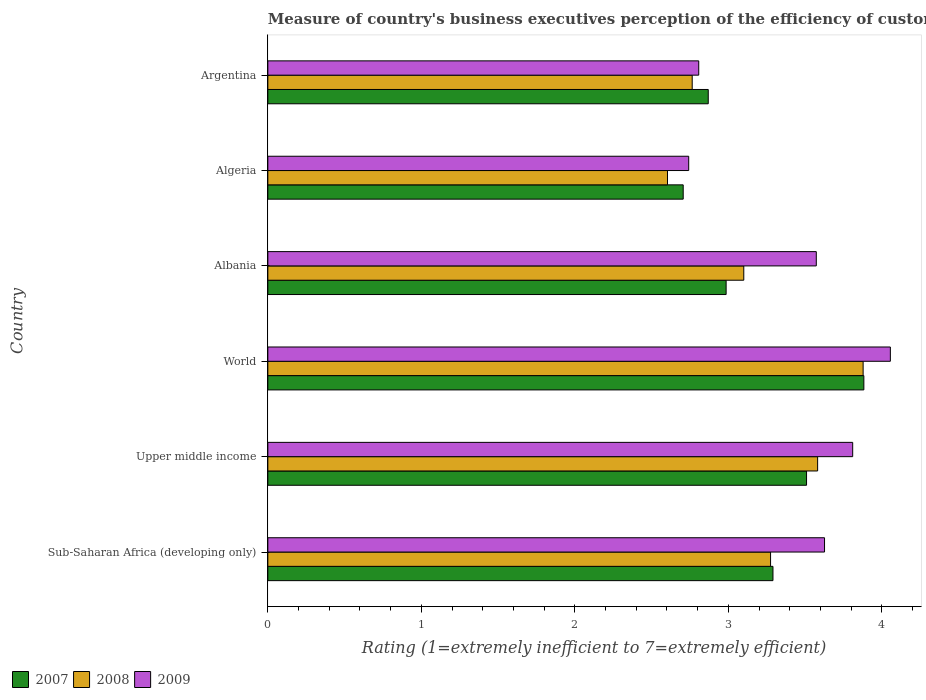How many groups of bars are there?
Provide a short and direct response. 6. Are the number of bars per tick equal to the number of legend labels?
Give a very brief answer. Yes. Are the number of bars on each tick of the Y-axis equal?
Offer a terse response. Yes. In how many cases, is the number of bars for a given country not equal to the number of legend labels?
Offer a very short reply. 0. What is the rating of the efficiency of customs procedure in 2008 in Sub-Saharan Africa (developing only)?
Make the answer very short. 3.27. Across all countries, what is the maximum rating of the efficiency of customs procedure in 2009?
Offer a terse response. 4.06. Across all countries, what is the minimum rating of the efficiency of customs procedure in 2009?
Make the answer very short. 2.74. In which country was the rating of the efficiency of customs procedure in 2007 maximum?
Offer a very short reply. World. In which country was the rating of the efficiency of customs procedure in 2009 minimum?
Offer a very short reply. Algeria. What is the total rating of the efficiency of customs procedure in 2008 in the graph?
Give a very brief answer. 19.2. What is the difference between the rating of the efficiency of customs procedure in 2008 in Argentina and that in World?
Provide a short and direct response. -1.11. What is the difference between the rating of the efficiency of customs procedure in 2008 in Upper middle income and the rating of the efficiency of customs procedure in 2009 in Sub-Saharan Africa (developing only)?
Make the answer very short. -0.04. What is the average rating of the efficiency of customs procedure in 2007 per country?
Make the answer very short. 3.21. What is the difference between the rating of the efficiency of customs procedure in 2008 and rating of the efficiency of customs procedure in 2007 in Argentina?
Your answer should be very brief. -0.1. What is the ratio of the rating of the efficiency of customs procedure in 2009 in Sub-Saharan Africa (developing only) to that in Upper middle income?
Ensure brevity in your answer.  0.95. Is the difference between the rating of the efficiency of customs procedure in 2008 in Algeria and Sub-Saharan Africa (developing only) greater than the difference between the rating of the efficiency of customs procedure in 2007 in Algeria and Sub-Saharan Africa (developing only)?
Provide a short and direct response. No. What is the difference between the highest and the second highest rating of the efficiency of customs procedure in 2008?
Ensure brevity in your answer.  0.3. What is the difference between the highest and the lowest rating of the efficiency of customs procedure in 2007?
Your answer should be compact. 1.18. In how many countries, is the rating of the efficiency of customs procedure in 2008 greater than the average rating of the efficiency of customs procedure in 2008 taken over all countries?
Your answer should be very brief. 3. Is the sum of the rating of the efficiency of customs procedure in 2008 in Albania and Argentina greater than the maximum rating of the efficiency of customs procedure in 2007 across all countries?
Your answer should be compact. Yes. What does the 2nd bar from the top in Albania represents?
Ensure brevity in your answer.  2008. Is it the case that in every country, the sum of the rating of the efficiency of customs procedure in 2008 and rating of the efficiency of customs procedure in 2009 is greater than the rating of the efficiency of customs procedure in 2007?
Give a very brief answer. Yes. Are all the bars in the graph horizontal?
Your answer should be compact. Yes. What is the difference between two consecutive major ticks on the X-axis?
Your response must be concise. 1. Does the graph contain any zero values?
Keep it short and to the point. No. How many legend labels are there?
Make the answer very short. 3. How are the legend labels stacked?
Provide a short and direct response. Horizontal. What is the title of the graph?
Provide a succinct answer. Measure of country's business executives perception of the efficiency of customs procedures. What is the label or title of the X-axis?
Give a very brief answer. Rating (1=extremely inefficient to 7=extremely efficient). What is the Rating (1=extremely inefficient to 7=extremely efficient) in 2007 in Sub-Saharan Africa (developing only)?
Offer a terse response. 3.29. What is the Rating (1=extremely inefficient to 7=extremely efficient) in 2008 in Sub-Saharan Africa (developing only)?
Your answer should be very brief. 3.27. What is the Rating (1=extremely inefficient to 7=extremely efficient) of 2009 in Sub-Saharan Africa (developing only)?
Your answer should be very brief. 3.63. What is the Rating (1=extremely inefficient to 7=extremely efficient) in 2007 in Upper middle income?
Offer a terse response. 3.51. What is the Rating (1=extremely inefficient to 7=extremely efficient) in 2008 in Upper middle income?
Your answer should be compact. 3.58. What is the Rating (1=extremely inefficient to 7=extremely efficient) of 2009 in Upper middle income?
Offer a very short reply. 3.81. What is the Rating (1=extremely inefficient to 7=extremely efficient) in 2007 in World?
Your response must be concise. 3.88. What is the Rating (1=extremely inefficient to 7=extremely efficient) in 2008 in World?
Keep it short and to the point. 3.88. What is the Rating (1=extremely inefficient to 7=extremely efficient) of 2009 in World?
Give a very brief answer. 4.06. What is the Rating (1=extremely inefficient to 7=extremely efficient) of 2007 in Albania?
Offer a terse response. 2.99. What is the Rating (1=extremely inefficient to 7=extremely efficient) in 2008 in Albania?
Keep it short and to the point. 3.1. What is the Rating (1=extremely inefficient to 7=extremely efficient) in 2009 in Albania?
Provide a short and direct response. 3.57. What is the Rating (1=extremely inefficient to 7=extremely efficient) in 2007 in Algeria?
Offer a terse response. 2.71. What is the Rating (1=extremely inefficient to 7=extremely efficient) of 2008 in Algeria?
Ensure brevity in your answer.  2.6. What is the Rating (1=extremely inefficient to 7=extremely efficient) in 2009 in Algeria?
Provide a short and direct response. 2.74. What is the Rating (1=extremely inefficient to 7=extremely efficient) in 2007 in Argentina?
Ensure brevity in your answer.  2.87. What is the Rating (1=extremely inefficient to 7=extremely efficient) in 2008 in Argentina?
Keep it short and to the point. 2.76. What is the Rating (1=extremely inefficient to 7=extremely efficient) of 2009 in Argentina?
Ensure brevity in your answer.  2.81. Across all countries, what is the maximum Rating (1=extremely inefficient to 7=extremely efficient) in 2007?
Your answer should be very brief. 3.88. Across all countries, what is the maximum Rating (1=extremely inefficient to 7=extremely efficient) of 2008?
Keep it short and to the point. 3.88. Across all countries, what is the maximum Rating (1=extremely inefficient to 7=extremely efficient) of 2009?
Keep it short and to the point. 4.06. Across all countries, what is the minimum Rating (1=extremely inefficient to 7=extremely efficient) in 2007?
Ensure brevity in your answer.  2.71. Across all countries, what is the minimum Rating (1=extremely inefficient to 7=extremely efficient) of 2008?
Offer a very short reply. 2.6. Across all countries, what is the minimum Rating (1=extremely inefficient to 7=extremely efficient) in 2009?
Offer a terse response. 2.74. What is the total Rating (1=extremely inefficient to 7=extremely efficient) in 2007 in the graph?
Offer a very short reply. 19.24. What is the total Rating (1=extremely inefficient to 7=extremely efficient) of 2008 in the graph?
Provide a short and direct response. 19.2. What is the total Rating (1=extremely inefficient to 7=extremely efficient) in 2009 in the graph?
Your answer should be very brief. 20.61. What is the difference between the Rating (1=extremely inefficient to 7=extremely efficient) in 2007 in Sub-Saharan Africa (developing only) and that in Upper middle income?
Make the answer very short. -0.22. What is the difference between the Rating (1=extremely inefficient to 7=extremely efficient) in 2008 in Sub-Saharan Africa (developing only) and that in Upper middle income?
Your answer should be very brief. -0.31. What is the difference between the Rating (1=extremely inefficient to 7=extremely efficient) in 2009 in Sub-Saharan Africa (developing only) and that in Upper middle income?
Ensure brevity in your answer.  -0.18. What is the difference between the Rating (1=extremely inefficient to 7=extremely efficient) in 2007 in Sub-Saharan Africa (developing only) and that in World?
Ensure brevity in your answer.  -0.59. What is the difference between the Rating (1=extremely inefficient to 7=extremely efficient) of 2008 in Sub-Saharan Africa (developing only) and that in World?
Make the answer very short. -0.6. What is the difference between the Rating (1=extremely inefficient to 7=extremely efficient) in 2009 in Sub-Saharan Africa (developing only) and that in World?
Ensure brevity in your answer.  -0.43. What is the difference between the Rating (1=extremely inefficient to 7=extremely efficient) of 2007 in Sub-Saharan Africa (developing only) and that in Albania?
Provide a succinct answer. 0.31. What is the difference between the Rating (1=extremely inefficient to 7=extremely efficient) of 2008 in Sub-Saharan Africa (developing only) and that in Albania?
Provide a short and direct response. 0.17. What is the difference between the Rating (1=extremely inefficient to 7=extremely efficient) of 2009 in Sub-Saharan Africa (developing only) and that in Albania?
Your answer should be compact. 0.05. What is the difference between the Rating (1=extremely inefficient to 7=extremely efficient) of 2007 in Sub-Saharan Africa (developing only) and that in Algeria?
Make the answer very short. 0.58. What is the difference between the Rating (1=extremely inefficient to 7=extremely efficient) in 2008 in Sub-Saharan Africa (developing only) and that in Algeria?
Your answer should be very brief. 0.67. What is the difference between the Rating (1=extremely inefficient to 7=extremely efficient) in 2009 in Sub-Saharan Africa (developing only) and that in Algeria?
Your answer should be very brief. 0.88. What is the difference between the Rating (1=extremely inefficient to 7=extremely efficient) in 2007 in Sub-Saharan Africa (developing only) and that in Argentina?
Your response must be concise. 0.42. What is the difference between the Rating (1=extremely inefficient to 7=extremely efficient) of 2008 in Sub-Saharan Africa (developing only) and that in Argentina?
Provide a short and direct response. 0.51. What is the difference between the Rating (1=extremely inefficient to 7=extremely efficient) of 2009 in Sub-Saharan Africa (developing only) and that in Argentina?
Provide a short and direct response. 0.82. What is the difference between the Rating (1=extremely inefficient to 7=extremely efficient) in 2007 in Upper middle income and that in World?
Provide a short and direct response. -0.37. What is the difference between the Rating (1=extremely inefficient to 7=extremely efficient) in 2008 in Upper middle income and that in World?
Provide a short and direct response. -0.3. What is the difference between the Rating (1=extremely inefficient to 7=extremely efficient) of 2009 in Upper middle income and that in World?
Give a very brief answer. -0.25. What is the difference between the Rating (1=extremely inefficient to 7=extremely efficient) of 2007 in Upper middle income and that in Albania?
Provide a succinct answer. 0.52. What is the difference between the Rating (1=extremely inefficient to 7=extremely efficient) of 2008 in Upper middle income and that in Albania?
Provide a short and direct response. 0.48. What is the difference between the Rating (1=extremely inefficient to 7=extremely efficient) of 2009 in Upper middle income and that in Albania?
Ensure brevity in your answer.  0.24. What is the difference between the Rating (1=extremely inefficient to 7=extremely efficient) in 2007 in Upper middle income and that in Algeria?
Your response must be concise. 0.8. What is the difference between the Rating (1=extremely inefficient to 7=extremely efficient) of 2008 in Upper middle income and that in Algeria?
Give a very brief answer. 0.98. What is the difference between the Rating (1=extremely inefficient to 7=extremely efficient) of 2009 in Upper middle income and that in Algeria?
Offer a very short reply. 1.07. What is the difference between the Rating (1=extremely inefficient to 7=extremely efficient) in 2007 in Upper middle income and that in Argentina?
Make the answer very short. 0.64. What is the difference between the Rating (1=extremely inefficient to 7=extremely efficient) in 2008 in Upper middle income and that in Argentina?
Ensure brevity in your answer.  0.82. What is the difference between the Rating (1=extremely inefficient to 7=extremely efficient) in 2007 in World and that in Albania?
Keep it short and to the point. 0.9. What is the difference between the Rating (1=extremely inefficient to 7=extremely efficient) in 2008 in World and that in Albania?
Provide a short and direct response. 0.78. What is the difference between the Rating (1=extremely inefficient to 7=extremely efficient) of 2009 in World and that in Albania?
Your answer should be compact. 0.48. What is the difference between the Rating (1=extremely inefficient to 7=extremely efficient) in 2007 in World and that in Algeria?
Ensure brevity in your answer.  1.18. What is the difference between the Rating (1=extremely inefficient to 7=extremely efficient) of 2008 in World and that in Algeria?
Provide a succinct answer. 1.27. What is the difference between the Rating (1=extremely inefficient to 7=extremely efficient) in 2009 in World and that in Algeria?
Offer a very short reply. 1.31. What is the difference between the Rating (1=extremely inefficient to 7=extremely efficient) of 2007 in World and that in Argentina?
Your answer should be very brief. 1.01. What is the difference between the Rating (1=extremely inefficient to 7=extremely efficient) in 2008 in World and that in Argentina?
Your answer should be very brief. 1.11. What is the difference between the Rating (1=extremely inefficient to 7=extremely efficient) of 2009 in World and that in Argentina?
Provide a short and direct response. 1.25. What is the difference between the Rating (1=extremely inefficient to 7=extremely efficient) of 2007 in Albania and that in Algeria?
Offer a very short reply. 0.28. What is the difference between the Rating (1=extremely inefficient to 7=extremely efficient) of 2008 in Albania and that in Algeria?
Give a very brief answer. 0.5. What is the difference between the Rating (1=extremely inefficient to 7=extremely efficient) in 2009 in Albania and that in Algeria?
Make the answer very short. 0.83. What is the difference between the Rating (1=extremely inefficient to 7=extremely efficient) of 2007 in Albania and that in Argentina?
Offer a very short reply. 0.12. What is the difference between the Rating (1=extremely inefficient to 7=extremely efficient) of 2008 in Albania and that in Argentina?
Ensure brevity in your answer.  0.34. What is the difference between the Rating (1=extremely inefficient to 7=extremely efficient) in 2009 in Albania and that in Argentina?
Ensure brevity in your answer.  0.77. What is the difference between the Rating (1=extremely inefficient to 7=extremely efficient) of 2007 in Algeria and that in Argentina?
Keep it short and to the point. -0.16. What is the difference between the Rating (1=extremely inefficient to 7=extremely efficient) of 2008 in Algeria and that in Argentina?
Your answer should be very brief. -0.16. What is the difference between the Rating (1=extremely inefficient to 7=extremely efficient) of 2009 in Algeria and that in Argentina?
Your answer should be compact. -0.07. What is the difference between the Rating (1=extremely inefficient to 7=extremely efficient) of 2007 in Sub-Saharan Africa (developing only) and the Rating (1=extremely inefficient to 7=extremely efficient) of 2008 in Upper middle income?
Your answer should be compact. -0.29. What is the difference between the Rating (1=extremely inefficient to 7=extremely efficient) of 2007 in Sub-Saharan Africa (developing only) and the Rating (1=extremely inefficient to 7=extremely efficient) of 2009 in Upper middle income?
Your answer should be compact. -0.52. What is the difference between the Rating (1=extremely inefficient to 7=extremely efficient) of 2008 in Sub-Saharan Africa (developing only) and the Rating (1=extremely inefficient to 7=extremely efficient) of 2009 in Upper middle income?
Provide a succinct answer. -0.54. What is the difference between the Rating (1=extremely inefficient to 7=extremely efficient) of 2007 in Sub-Saharan Africa (developing only) and the Rating (1=extremely inefficient to 7=extremely efficient) of 2008 in World?
Make the answer very short. -0.59. What is the difference between the Rating (1=extremely inefficient to 7=extremely efficient) of 2007 in Sub-Saharan Africa (developing only) and the Rating (1=extremely inefficient to 7=extremely efficient) of 2009 in World?
Provide a short and direct response. -0.76. What is the difference between the Rating (1=extremely inefficient to 7=extremely efficient) in 2008 in Sub-Saharan Africa (developing only) and the Rating (1=extremely inefficient to 7=extremely efficient) in 2009 in World?
Make the answer very short. -0.78. What is the difference between the Rating (1=extremely inefficient to 7=extremely efficient) in 2007 in Sub-Saharan Africa (developing only) and the Rating (1=extremely inefficient to 7=extremely efficient) in 2008 in Albania?
Make the answer very short. 0.19. What is the difference between the Rating (1=extremely inefficient to 7=extremely efficient) in 2007 in Sub-Saharan Africa (developing only) and the Rating (1=extremely inefficient to 7=extremely efficient) in 2009 in Albania?
Your response must be concise. -0.28. What is the difference between the Rating (1=extremely inefficient to 7=extremely efficient) in 2008 in Sub-Saharan Africa (developing only) and the Rating (1=extremely inefficient to 7=extremely efficient) in 2009 in Albania?
Give a very brief answer. -0.3. What is the difference between the Rating (1=extremely inefficient to 7=extremely efficient) in 2007 in Sub-Saharan Africa (developing only) and the Rating (1=extremely inefficient to 7=extremely efficient) in 2008 in Algeria?
Offer a very short reply. 0.69. What is the difference between the Rating (1=extremely inefficient to 7=extremely efficient) in 2007 in Sub-Saharan Africa (developing only) and the Rating (1=extremely inefficient to 7=extremely efficient) in 2009 in Algeria?
Your answer should be very brief. 0.55. What is the difference between the Rating (1=extremely inefficient to 7=extremely efficient) of 2008 in Sub-Saharan Africa (developing only) and the Rating (1=extremely inefficient to 7=extremely efficient) of 2009 in Algeria?
Offer a terse response. 0.53. What is the difference between the Rating (1=extremely inefficient to 7=extremely efficient) of 2007 in Sub-Saharan Africa (developing only) and the Rating (1=extremely inefficient to 7=extremely efficient) of 2008 in Argentina?
Provide a succinct answer. 0.53. What is the difference between the Rating (1=extremely inefficient to 7=extremely efficient) of 2007 in Sub-Saharan Africa (developing only) and the Rating (1=extremely inefficient to 7=extremely efficient) of 2009 in Argentina?
Your response must be concise. 0.48. What is the difference between the Rating (1=extremely inefficient to 7=extremely efficient) in 2008 in Sub-Saharan Africa (developing only) and the Rating (1=extremely inefficient to 7=extremely efficient) in 2009 in Argentina?
Provide a succinct answer. 0.47. What is the difference between the Rating (1=extremely inefficient to 7=extremely efficient) of 2007 in Upper middle income and the Rating (1=extremely inefficient to 7=extremely efficient) of 2008 in World?
Offer a terse response. -0.37. What is the difference between the Rating (1=extremely inefficient to 7=extremely efficient) of 2007 in Upper middle income and the Rating (1=extremely inefficient to 7=extremely efficient) of 2009 in World?
Give a very brief answer. -0.55. What is the difference between the Rating (1=extremely inefficient to 7=extremely efficient) in 2008 in Upper middle income and the Rating (1=extremely inefficient to 7=extremely efficient) in 2009 in World?
Provide a succinct answer. -0.47. What is the difference between the Rating (1=extremely inefficient to 7=extremely efficient) of 2007 in Upper middle income and the Rating (1=extremely inefficient to 7=extremely efficient) of 2008 in Albania?
Keep it short and to the point. 0.41. What is the difference between the Rating (1=extremely inefficient to 7=extremely efficient) of 2007 in Upper middle income and the Rating (1=extremely inefficient to 7=extremely efficient) of 2009 in Albania?
Offer a very short reply. -0.06. What is the difference between the Rating (1=extremely inefficient to 7=extremely efficient) of 2008 in Upper middle income and the Rating (1=extremely inefficient to 7=extremely efficient) of 2009 in Albania?
Your answer should be very brief. 0.01. What is the difference between the Rating (1=extremely inefficient to 7=extremely efficient) in 2007 in Upper middle income and the Rating (1=extremely inefficient to 7=extremely efficient) in 2008 in Algeria?
Make the answer very short. 0.91. What is the difference between the Rating (1=extremely inefficient to 7=extremely efficient) of 2007 in Upper middle income and the Rating (1=extremely inefficient to 7=extremely efficient) of 2009 in Algeria?
Ensure brevity in your answer.  0.77. What is the difference between the Rating (1=extremely inefficient to 7=extremely efficient) of 2008 in Upper middle income and the Rating (1=extremely inefficient to 7=extremely efficient) of 2009 in Algeria?
Keep it short and to the point. 0.84. What is the difference between the Rating (1=extremely inefficient to 7=extremely efficient) in 2007 in Upper middle income and the Rating (1=extremely inefficient to 7=extremely efficient) in 2008 in Argentina?
Your answer should be compact. 0.74. What is the difference between the Rating (1=extremely inefficient to 7=extremely efficient) in 2007 in Upper middle income and the Rating (1=extremely inefficient to 7=extremely efficient) in 2009 in Argentina?
Give a very brief answer. 0.7. What is the difference between the Rating (1=extremely inefficient to 7=extremely efficient) in 2008 in Upper middle income and the Rating (1=extremely inefficient to 7=extremely efficient) in 2009 in Argentina?
Provide a short and direct response. 0.77. What is the difference between the Rating (1=extremely inefficient to 7=extremely efficient) in 2007 in World and the Rating (1=extremely inefficient to 7=extremely efficient) in 2008 in Albania?
Provide a succinct answer. 0.78. What is the difference between the Rating (1=extremely inefficient to 7=extremely efficient) in 2007 in World and the Rating (1=extremely inefficient to 7=extremely efficient) in 2009 in Albania?
Keep it short and to the point. 0.31. What is the difference between the Rating (1=extremely inefficient to 7=extremely efficient) in 2008 in World and the Rating (1=extremely inefficient to 7=extremely efficient) in 2009 in Albania?
Keep it short and to the point. 0.31. What is the difference between the Rating (1=extremely inefficient to 7=extremely efficient) of 2007 in World and the Rating (1=extremely inefficient to 7=extremely efficient) of 2008 in Algeria?
Offer a very short reply. 1.28. What is the difference between the Rating (1=extremely inefficient to 7=extremely efficient) of 2007 in World and the Rating (1=extremely inefficient to 7=extremely efficient) of 2009 in Algeria?
Your response must be concise. 1.14. What is the difference between the Rating (1=extremely inefficient to 7=extremely efficient) of 2008 in World and the Rating (1=extremely inefficient to 7=extremely efficient) of 2009 in Algeria?
Make the answer very short. 1.14. What is the difference between the Rating (1=extremely inefficient to 7=extremely efficient) in 2007 in World and the Rating (1=extremely inefficient to 7=extremely efficient) in 2008 in Argentina?
Your answer should be very brief. 1.12. What is the difference between the Rating (1=extremely inefficient to 7=extremely efficient) in 2007 in World and the Rating (1=extremely inefficient to 7=extremely efficient) in 2009 in Argentina?
Give a very brief answer. 1.08. What is the difference between the Rating (1=extremely inefficient to 7=extremely efficient) of 2008 in World and the Rating (1=extremely inefficient to 7=extremely efficient) of 2009 in Argentina?
Offer a terse response. 1.07. What is the difference between the Rating (1=extremely inefficient to 7=extremely efficient) in 2007 in Albania and the Rating (1=extremely inefficient to 7=extremely efficient) in 2008 in Algeria?
Offer a terse response. 0.38. What is the difference between the Rating (1=extremely inefficient to 7=extremely efficient) in 2007 in Albania and the Rating (1=extremely inefficient to 7=extremely efficient) in 2009 in Algeria?
Give a very brief answer. 0.24. What is the difference between the Rating (1=extremely inefficient to 7=extremely efficient) in 2008 in Albania and the Rating (1=extremely inefficient to 7=extremely efficient) in 2009 in Algeria?
Your answer should be compact. 0.36. What is the difference between the Rating (1=extremely inefficient to 7=extremely efficient) in 2007 in Albania and the Rating (1=extremely inefficient to 7=extremely efficient) in 2008 in Argentina?
Offer a very short reply. 0.22. What is the difference between the Rating (1=extremely inefficient to 7=extremely efficient) of 2007 in Albania and the Rating (1=extremely inefficient to 7=extremely efficient) of 2009 in Argentina?
Offer a very short reply. 0.18. What is the difference between the Rating (1=extremely inefficient to 7=extremely efficient) of 2008 in Albania and the Rating (1=extremely inefficient to 7=extremely efficient) of 2009 in Argentina?
Your answer should be compact. 0.29. What is the difference between the Rating (1=extremely inefficient to 7=extremely efficient) of 2007 in Algeria and the Rating (1=extremely inefficient to 7=extremely efficient) of 2008 in Argentina?
Your answer should be compact. -0.06. What is the difference between the Rating (1=extremely inefficient to 7=extremely efficient) in 2007 in Algeria and the Rating (1=extremely inefficient to 7=extremely efficient) in 2009 in Argentina?
Offer a very short reply. -0.1. What is the difference between the Rating (1=extremely inefficient to 7=extremely efficient) of 2008 in Algeria and the Rating (1=extremely inefficient to 7=extremely efficient) of 2009 in Argentina?
Offer a terse response. -0.2. What is the average Rating (1=extremely inefficient to 7=extremely efficient) of 2007 per country?
Make the answer very short. 3.21. What is the average Rating (1=extremely inefficient to 7=extremely efficient) of 2008 per country?
Your answer should be very brief. 3.2. What is the average Rating (1=extremely inefficient to 7=extremely efficient) in 2009 per country?
Your answer should be compact. 3.44. What is the difference between the Rating (1=extremely inefficient to 7=extremely efficient) in 2007 and Rating (1=extremely inefficient to 7=extremely efficient) in 2008 in Sub-Saharan Africa (developing only)?
Give a very brief answer. 0.02. What is the difference between the Rating (1=extremely inefficient to 7=extremely efficient) in 2007 and Rating (1=extremely inefficient to 7=extremely efficient) in 2009 in Sub-Saharan Africa (developing only)?
Offer a very short reply. -0.34. What is the difference between the Rating (1=extremely inefficient to 7=extremely efficient) of 2008 and Rating (1=extremely inefficient to 7=extremely efficient) of 2009 in Sub-Saharan Africa (developing only)?
Give a very brief answer. -0.35. What is the difference between the Rating (1=extremely inefficient to 7=extremely efficient) in 2007 and Rating (1=extremely inefficient to 7=extremely efficient) in 2008 in Upper middle income?
Your answer should be compact. -0.07. What is the difference between the Rating (1=extremely inefficient to 7=extremely efficient) of 2007 and Rating (1=extremely inefficient to 7=extremely efficient) of 2009 in Upper middle income?
Make the answer very short. -0.3. What is the difference between the Rating (1=extremely inefficient to 7=extremely efficient) of 2008 and Rating (1=extremely inefficient to 7=extremely efficient) of 2009 in Upper middle income?
Your answer should be very brief. -0.23. What is the difference between the Rating (1=extremely inefficient to 7=extremely efficient) in 2007 and Rating (1=extremely inefficient to 7=extremely efficient) in 2008 in World?
Keep it short and to the point. 0. What is the difference between the Rating (1=extremely inefficient to 7=extremely efficient) in 2007 and Rating (1=extremely inefficient to 7=extremely efficient) in 2009 in World?
Provide a succinct answer. -0.17. What is the difference between the Rating (1=extremely inefficient to 7=extremely efficient) of 2008 and Rating (1=extremely inefficient to 7=extremely efficient) of 2009 in World?
Your answer should be very brief. -0.18. What is the difference between the Rating (1=extremely inefficient to 7=extremely efficient) in 2007 and Rating (1=extremely inefficient to 7=extremely efficient) in 2008 in Albania?
Ensure brevity in your answer.  -0.12. What is the difference between the Rating (1=extremely inefficient to 7=extremely efficient) of 2007 and Rating (1=extremely inefficient to 7=extremely efficient) of 2009 in Albania?
Provide a succinct answer. -0.59. What is the difference between the Rating (1=extremely inefficient to 7=extremely efficient) of 2008 and Rating (1=extremely inefficient to 7=extremely efficient) of 2009 in Albania?
Keep it short and to the point. -0.47. What is the difference between the Rating (1=extremely inefficient to 7=extremely efficient) of 2007 and Rating (1=extremely inefficient to 7=extremely efficient) of 2008 in Algeria?
Make the answer very short. 0.1. What is the difference between the Rating (1=extremely inefficient to 7=extremely efficient) of 2007 and Rating (1=extremely inefficient to 7=extremely efficient) of 2009 in Algeria?
Give a very brief answer. -0.04. What is the difference between the Rating (1=extremely inefficient to 7=extremely efficient) in 2008 and Rating (1=extremely inefficient to 7=extremely efficient) in 2009 in Algeria?
Offer a terse response. -0.14. What is the difference between the Rating (1=extremely inefficient to 7=extremely efficient) in 2007 and Rating (1=extremely inefficient to 7=extremely efficient) in 2008 in Argentina?
Offer a terse response. 0.1. What is the difference between the Rating (1=extremely inefficient to 7=extremely efficient) of 2007 and Rating (1=extremely inefficient to 7=extremely efficient) of 2009 in Argentina?
Your answer should be very brief. 0.06. What is the difference between the Rating (1=extremely inefficient to 7=extremely efficient) in 2008 and Rating (1=extremely inefficient to 7=extremely efficient) in 2009 in Argentina?
Ensure brevity in your answer.  -0.04. What is the ratio of the Rating (1=extremely inefficient to 7=extremely efficient) of 2007 in Sub-Saharan Africa (developing only) to that in Upper middle income?
Your answer should be compact. 0.94. What is the ratio of the Rating (1=extremely inefficient to 7=extremely efficient) in 2008 in Sub-Saharan Africa (developing only) to that in Upper middle income?
Make the answer very short. 0.91. What is the ratio of the Rating (1=extremely inefficient to 7=extremely efficient) in 2009 in Sub-Saharan Africa (developing only) to that in Upper middle income?
Your response must be concise. 0.95. What is the ratio of the Rating (1=extremely inefficient to 7=extremely efficient) of 2007 in Sub-Saharan Africa (developing only) to that in World?
Offer a very short reply. 0.85. What is the ratio of the Rating (1=extremely inefficient to 7=extremely efficient) in 2008 in Sub-Saharan Africa (developing only) to that in World?
Provide a succinct answer. 0.84. What is the ratio of the Rating (1=extremely inefficient to 7=extremely efficient) in 2009 in Sub-Saharan Africa (developing only) to that in World?
Provide a short and direct response. 0.89. What is the ratio of the Rating (1=extremely inefficient to 7=extremely efficient) in 2007 in Sub-Saharan Africa (developing only) to that in Albania?
Provide a short and direct response. 1.1. What is the ratio of the Rating (1=extremely inefficient to 7=extremely efficient) in 2008 in Sub-Saharan Africa (developing only) to that in Albania?
Your answer should be compact. 1.06. What is the ratio of the Rating (1=extremely inefficient to 7=extremely efficient) in 2007 in Sub-Saharan Africa (developing only) to that in Algeria?
Your response must be concise. 1.22. What is the ratio of the Rating (1=extremely inefficient to 7=extremely efficient) of 2008 in Sub-Saharan Africa (developing only) to that in Algeria?
Your response must be concise. 1.26. What is the ratio of the Rating (1=extremely inefficient to 7=extremely efficient) in 2009 in Sub-Saharan Africa (developing only) to that in Algeria?
Offer a terse response. 1.32. What is the ratio of the Rating (1=extremely inefficient to 7=extremely efficient) of 2007 in Sub-Saharan Africa (developing only) to that in Argentina?
Provide a short and direct response. 1.15. What is the ratio of the Rating (1=extremely inefficient to 7=extremely efficient) of 2008 in Sub-Saharan Africa (developing only) to that in Argentina?
Offer a very short reply. 1.18. What is the ratio of the Rating (1=extremely inefficient to 7=extremely efficient) in 2009 in Sub-Saharan Africa (developing only) to that in Argentina?
Offer a very short reply. 1.29. What is the ratio of the Rating (1=extremely inefficient to 7=extremely efficient) in 2007 in Upper middle income to that in World?
Provide a short and direct response. 0.9. What is the ratio of the Rating (1=extremely inefficient to 7=extremely efficient) in 2008 in Upper middle income to that in World?
Offer a very short reply. 0.92. What is the ratio of the Rating (1=extremely inefficient to 7=extremely efficient) of 2009 in Upper middle income to that in World?
Provide a succinct answer. 0.94. What is the ratio of the Rating (1=extremely inefficient to 7=extremely efficient) in 2007 in Upper middle income to that in Albania?
Ensure brevity in your answer.  1.18. What is the ratio of the Rating (1=extremely inefficient to 7=extremely efficient) in 2008 in Upper middle income to that in Albania?
Keep it short and to the point. 1.16. What is the ratio of the Rating (1=extremely inefficient to 7=extremely efficient) in 2009 in Upper middle income to that in Albania?
Make the answer very short. 1.07. What is the ratio of the Rating (1=extremely inefficient to 7=extremely efficient) in 2007 in Upper middle income to that in Algeria?
Provide a short and direct response. 1.3. What is the ratio of the Rating (1=extremely inefficient to 7=extremely efficient) of 2008 in Upper middle income to that in Algeria?
Provide a succinct answer. 1.38. What is the ratio of the Rating (1=extremely inefficient to 7=extremely efficient) of 2009 in Upper middle income to that in Algeria?
Offer a terse response. 1.39. What is the ratio of the Rating (1=extremely inefficient to 7=extremely efficient) in 2007 in Upper middle income to that in Argentina?
Provide a short and direct response. 1.22. What is the ratio of the Rating (1=extremely inefficient to 7=extremely efficient) of 2008 in Upper middle income to that in Argentina?
Provide a short and direct response. 1.3. What is the ratio of the Rating (1=extremely inefficient to 7=extremely efficient) in 2009 in Upper middle income to that in Argentina?
Provide a succinct answer. 1.36. What is the ratio of the Rating (1=extremely inefficient to 7=extremely efficient) in 2007 in World to that in Albania?
Make the answer very short. 1.3. What is the ratio of the Rating (1=extremely inefficient to 7=extremely efficient) of 2008 in World to that in Albania?
Your response must be concise. 1.25. What is the ratio of the Rating (1=extremely inefficient to 7=extremely efficient) of 2009 in World to that in Albania?
Offer a terse response. 1.14. What is the ratio of the Rating (1=extremely inefficient to 7=extremely efficient) in 2007 in World to that in Algeria?
Your answer should be very brief. 1.43. What is the ratio of the Rating (1=extremely inefficient to 7=extremely efficient) in 2008 in World to that in Algeria?
Provide a short and direct response. 1.49. What is the ratio of the Rating (1=extremely inefficient to 7=extremely efficient) of 2009 in World to that in Algeria?
Keep it short and to the point. 1.48. What is the ratio of the Rating (1=extremely inefficient to 7=extremely efficient) in 2007 in World to that in Argentina?
Provide a short and direct response. 1.35. What is the ratio of the Rating (1=extremely inefficient to 7=extremely efficient) of 2008 in World to that in Argentina?
Provide a short and direct response. 1.4. What is the ratio of the Rating (1=extremely inefficient to 7=extremely efficient) in 2009 in World to that in Argentina?
Your response must be concise. 1.44. What is the ratio of the Rating (1=extremely inefficient to 7=extremely efficient) of 2007 in Albania to that in Algeria?
Provide a succinct answer. 1.1. What is the ratio of the Rating (1=extremely inefficient to 7=extremely efficient) in 2008 in Albania to that in Algeria?
Make the answer very short. 1.19. What is the ratio of the Rating (1=extremely inefficient to 7=extremely efficient) of 2009 in Albania to that in Algeria?
Keep it short and to the point. 1.3. What is the ratio of the Rating (1=extremely inefficient to 7=extremely efficient) in 2007 in Albania to that in Argentina?
Offer a very short reply. 1.04. What is the ratio of the Rating (1=extremely inefficient to 7=extremely efficient) in 2008 in Albania to that in Argentina?
Ensure brevity in your answer.  1.12. What is the ratio of the Rating (1=extremely inefficient to 7=extremely efficient) in 2009 in Albania to that in Argentina?
Keep it short and to the point. 1.27. What is the ratio of the Rating (1=extremely inefficient to 7=extremely efficient) in 2007 in Algeria to that in Argentina?
Offer a very short reply. 0.94. What is the ratio of the Rating (1=extremely inefficient to 7=extremely efficient) of 2008 in Algeria to that in Argentina?
Offer a very short reply. 0.94. What is the ratio of the Rating (1=extremely inefficient to 7=extremely efficient) in 2009 in Algeria to that in Argentina?
Ensure brevity in your answer.  0.98. What is the difference between the highest and the second highest Rating (1=extremely inefficient to 7=extremely efficient) in 2007?
Offer a very short reply. 0.37. What is the difference between the highest and the second highest Rating (1=extremely inefficient to 7=extremely efficient) in 2008?
Provide a short and direct response. 0.3. What is the difference between the highest and the second highest Rating (1=extremely inefficient to 7=extremely efficient) in 2009?
Your response must be concise. 0.25. What is the difference between the highest and the lowest Rating (1=extremely inefficient to 7=extremely efficient) of 2007?
Your answer should be very brief. 1.18. What is the difference between the highest and the lowest Rating (1=extremely inefficient to 7=extremely efficient) in 2008?
Offer a terse response. 1.27. What is the difference between the highest and the lowest Rating (1=extremely inefficient to 7=extremely efficient) in 2009?
Make the answer very short. 1.31. 